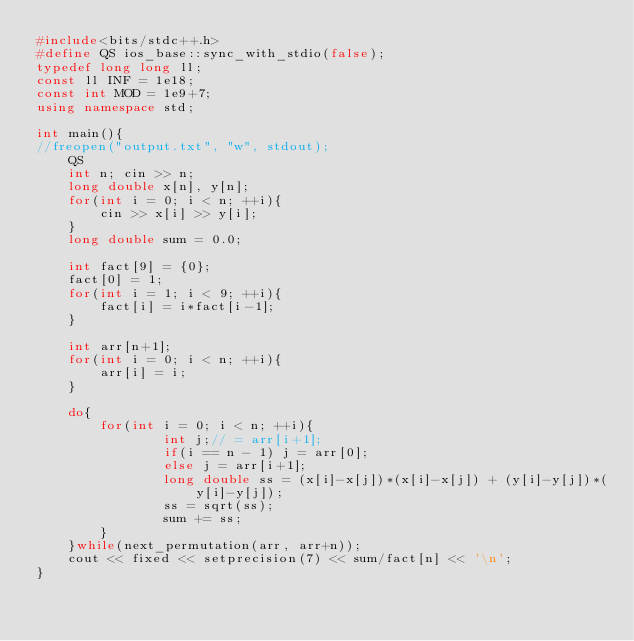Convert code to text. <code><loc_0><loc_0><loc_500><loc_500><_C++_>#include<bits/stdc++.h>
#define QS ios_base::sync_with_stdio(false);
typedef long long ll;
const ll INF = 1e18;
const int MOD = 1e9+7;
using namespace std;

int main(){
//freopen("output.txt", "w", stdout);
    QS
    int n; cin >> n;
    long double x[n], y[n];
    for(int i = 0; i < n; ++i){
        cin >> x[i] >> y[i];
    }
    long double sum = 0.0;

    int fact[9] = {0};
    fact[0] = 1;
    for(int i = 1; i < 9; ++i){
        fact[i] = i*fact[i-1];
    }

    int arr[n+1];
    for(int i = 0; i < n; ++i){
        arr[i] = i;
    }

    do{
        for(int i = 0; i < n; ++i){
                int j;// = arr[i+1];
                if(i == n - 1) j = arr[0];
                else j = arr[i+1];
                long double ss = (x[i]-x[j])*(x[i]-x[j]) + (y[i]-y[j])*(y[i]-y[j]);
                ss = sqrt(ss);
                sum += ss;
        }
    }while(next_permutation(arr, arr+n));
    cout << fixed << setprecision(7) << sum/fact[n] << '\n';
}
</code> 